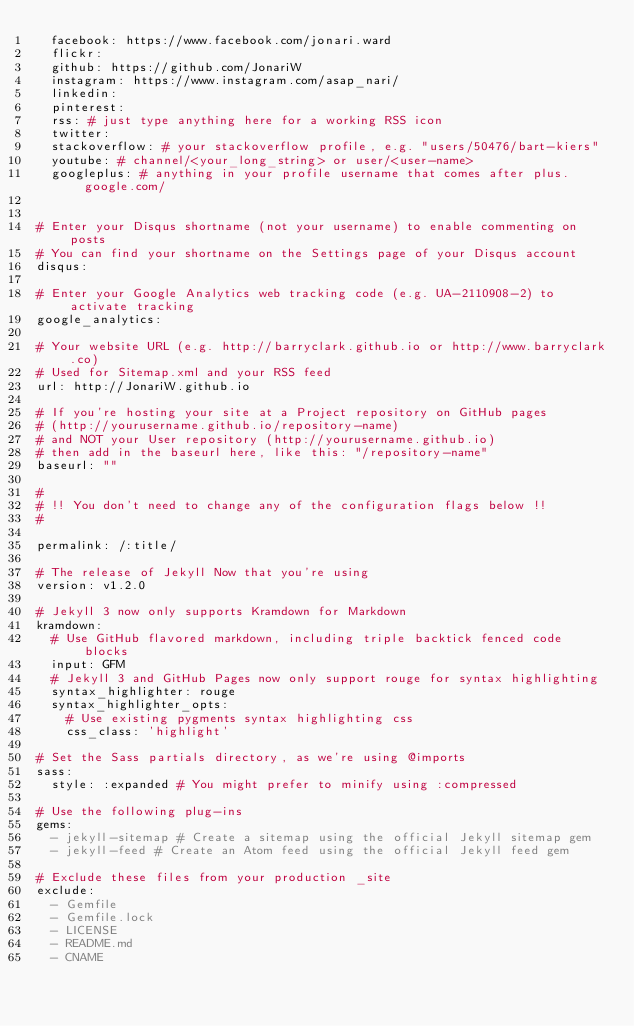Convert code to text. <code><loc_0><loc_0><loc_500><loc_500><_YAML_>  facebook: https://www.facebook.com/jonari.ward
  flickr:
  github: https://github.com/JonariW
  instagram: https://www.instagram.com/asap_nari/
  linkedin:
  pinterest:
  rss: # just type anything here for a working RSS icon
  twitter: 
  stackoverflow: # your stackoverflow profile, e.g. "users/50476/bart-kiers"
  youtube: # channel/<your_long_string> or user/<user-name>
  googleplus: # anything in your profile username that comes after plus.google.com/


# Enter your Disqus shortname (not your username) to enable commenting on posts
# You can find your shortname on the Settings page of your Disqus account
disqus:

# Enter your Google Analytics web tracking code (e.g. UA-2110908-2) to activate tracking
google_analytics:

# Your website URL (e.g. http://barryclark.github.io or http://www.barryclark.co)
# Used for Sitemap.xml and your RSS feed
url: http://JonariW.github.io

# If you're hosting your site at a Project repository on GitHub pages
# (http://yourusername.github.io/repository-name)
# and NOT your User repository (http://yourusername.github.io)
# then add in the baseurl here, like this: "/repository-name"
baseurl: ""

#
# !! You don't need to change any of the configuration flags below !!
#

permalink: /:title/

# The release of Jekyll Now that you're using
version: v1.2.0

# Jekyll 3 now only supports Kramdown for Markdown
kramdown:
  # Use GitHub flavored markdown, including triple backtick fenced code blocks
  input: GFM
  # Jekyll 3 and GitHub Pages now only support rouge for syntax highlighting
  syntax_highlighter: rouge
  syntax_highlighter_opts:
    # Use existing pygments syntax highlighting css
    css_class: 'highlight'

# Set the Sass partials directory, as we're using @imports
sass:
  style: :expanded # You might prefer to minify using :compressed

# Use the following plug-ins
gems:
  - jekyll-sitemap # Create a sitemap using the official Jekyll sitemap gem
  - jekyll-feed # Create an Atom feed using the official Jekyll feed gem

# Exclude these files from your production _site
exclude:
  - Gemfile
  - Gemfile.lock
  - LICENSE
  - README.md
  - CNAME
</code> 